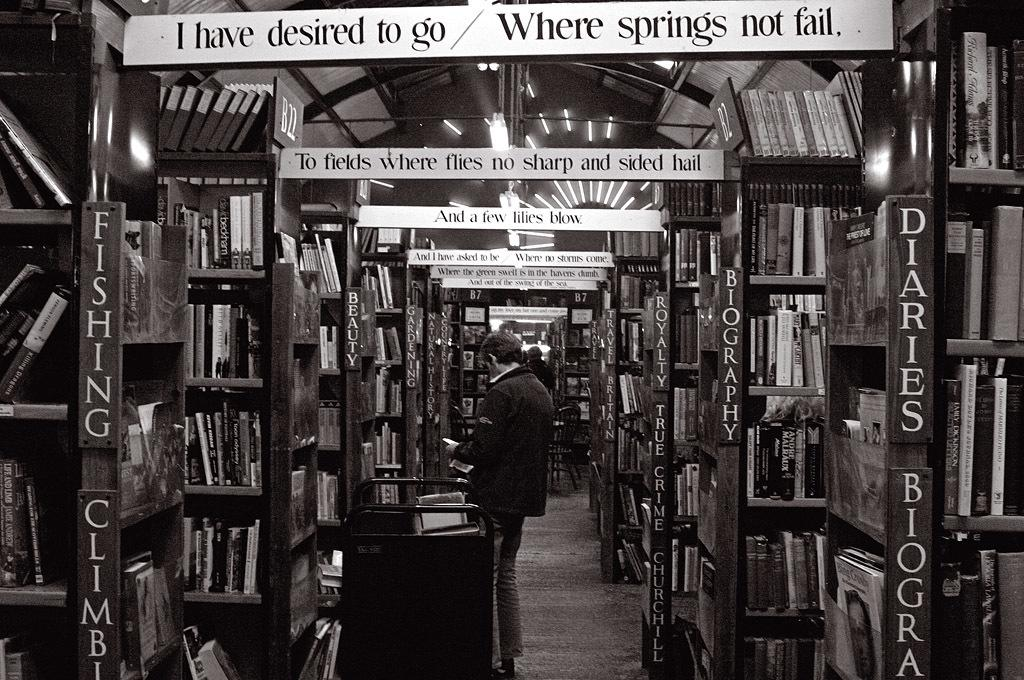<image>
Summarize the visual content of the image. The closest sign hanging on the wall says "I have desired to go / Where springs not fail." 